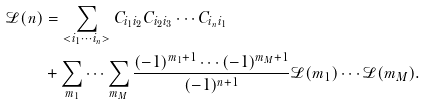Convert formula to latex. <formula><loc_0><loc_0><loc_500><loc_500>\mathcal { L } ( n ) & = \sum _ { < i _ { 1 } \cdots i _ { n } > } C _ { i _ { 1 } i _ { 2 } } C _ { i _ { 2 } i _ { 3 } } \cdots C _ { i _ { n } i _ { 1 } } \\ & + \sum _ { m _ { 1 } } \cdots \sum _ { m _ { M } } \frac { ( - 1 ) ^ { m _ { 1 } + 1 } \cdots ( - 1 ) ^ { m _ { M } + 1 } } { ( - 1 ) ^ { n + 1 } } \mathcal { L } ( m _ { 1 } ) \cdots \mathcal { L } ( m _ { M } ) .</formula> 